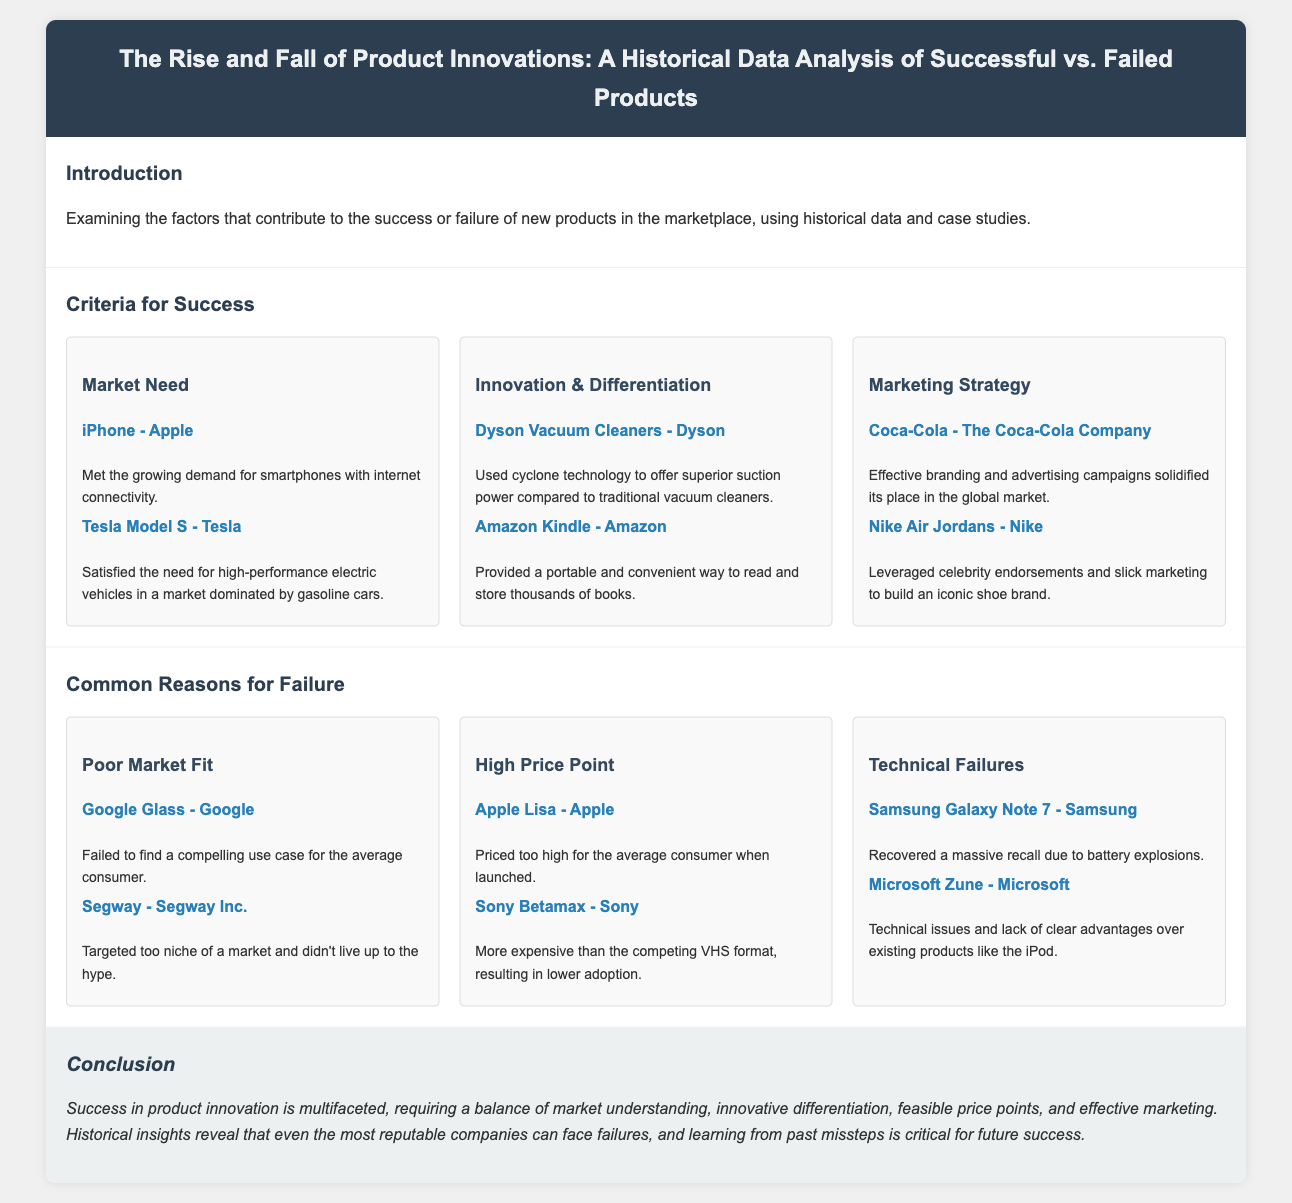what is the title of the infographic? The title provides insight into the subject matter covered in the document.
Answer: The Rise and Fall of Product Innovations: A Historical Data Analysis of Successful vs. Failed Products who is associated with the iPhone? This question examines the relationship between a specific product and its creator.
Answer: Apple what is a common reason for product failure according to the document? This question identifies one of the primary factors influencing the failure of products as discussed.
Answer: Poor Market Fit which product is mentioned for satisfying the need for high-performance electric vehicles? This question seeks to identify a specific example provided in the document regarding innovation.
Answer: Tesla Model S what is one criterion for product success? This question asks for a general category from the document outlining what leads to successful products.
Answer: Marketing Strategy what does the document suggest is crucial for future product success? This question explores the overarching message of the document regarding lessons learned.
Answer: Learning from past missteps what year is associated with the launch of the Apple Lisa? This question refers to a critical moment in tech product history as outlined in the document.
Answer: Not specified which company effectively used celebrity endorsements? This question connects a marketing strategy to a specific entity mentioned in the infographic.
Answer: Nike 